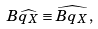<formula> <loc_0><loc_0><loc_500><loc_500>B \widehat { q _ { X } } \equiv \widehat { B q _ { X } } ,</formula> 